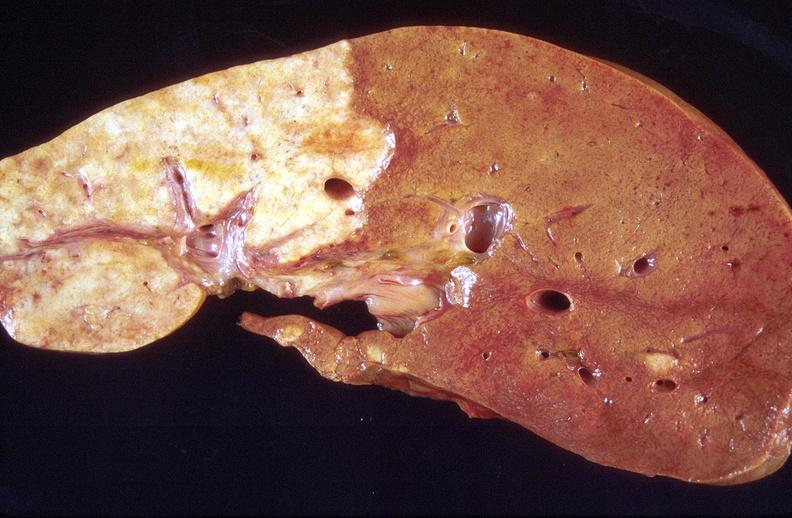s lesion present?
Answer the question using a single word or phrase. No 